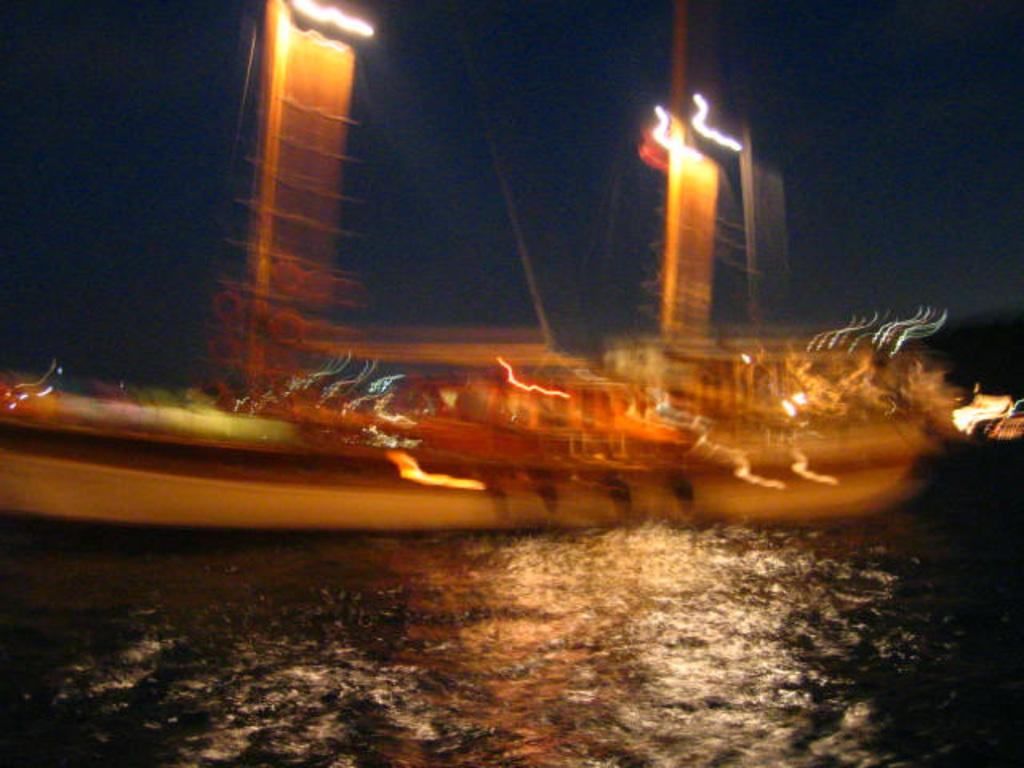What is the main subject of the image? The main subject of the image is a boat. Where is the boat located? The boat is sailing on a river. What is the rate of the boat's speed in the image? The provided facts do not mention the speed of the boat, so we cannot determine the rate of the boat's speed in the image. 